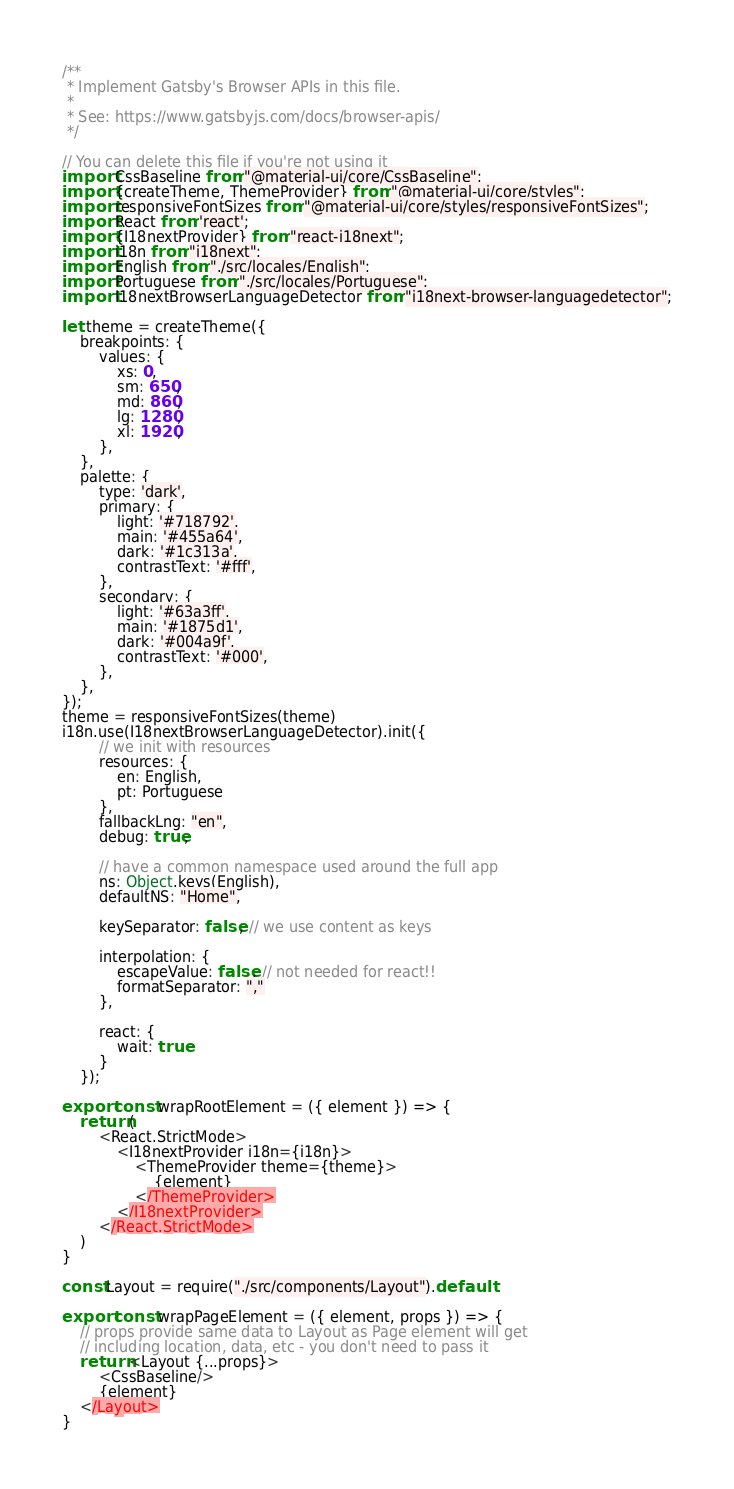Convert code to text. <code><loc_0><loc_0><loc_500><loc_500><_JavaScript_>/**
 * Implement Gatsby's Browser APIs in this file.
 *
 * See: https://www.gatsbyjs.com/docs/browser-apis/
 */

// You can delete this file if you're not using it
import CssBaseline from "@material-ui/core/CssBaseline";
import {createTheme, ThemeProvider} from "@material-ui/core/styles";
import responsiveFontSizes from "@material-ui/core/styles/responsiveFontSizes";
import React from 'react';
import {I18nextProvider} from "react-i18next";
import i18n from "i18next";
import English from "./src/locales/English";
import Portuguese from "./src/locales/Portuguese";
import I18nextBrowserLanguageDetector from "i18next-browser-languagedetector";

let theme = createTheme({
    breakpoints: {
        values: {
            xs: 0,
            sm: 650,
            md: 860,
            lg: 1280,
            xl: 1920,
        },
    },
    palette: {
        type: 'dark',
        primary: {
            light: '#718792',
            main: '#455a64',
            dark: '#1c313a',
            contrastText: '#fff',
        },
        secondary: {
            light: '#63a3ff',
            main: '#1875d1',
            dark: '#004a9f',
            contrastText: '#000',
        },
    },
});
theme = responsiveFontSizes(theme)
i18n.use(I18nextBrowserLanguageDetector).init({
        // we init with resources
        resources: {
            en: English,
            pt: Portuguese
        },
        fallbackLng: "en",
        debug: true,

        // have a common namespace used around the full app
        ns: Object.keys(English),
        defaultNS: "Home",

        keySeparator: false, // we use content as keys

        interpolation: {
            escapeValue: false, // not needed for react!!
            formatSeparator: ","
        },

        react: {
            wait: true
        }
    });

export const wrapRootElement = ({ element }) => {
    return (
        <React.StrictMode>
            <I18nextProvider i18n={i18n}>
                <ThemeProvider theme={theme}>
                    {element}
                </ThemeProvider>
            </I18nextProvider>
        </React.StrictMode>
    )
}

const Layout = require("./src/components/Layout").default

export const wrapPageElement = ({ element, props }) => {
    // props provide same data to Layout as Page element will get
    // including location, data, etc - you don't need to pass it
    return <Layout {...props}>
        <CssBaseline/>
        {element}
    </Layout>
}</code> 